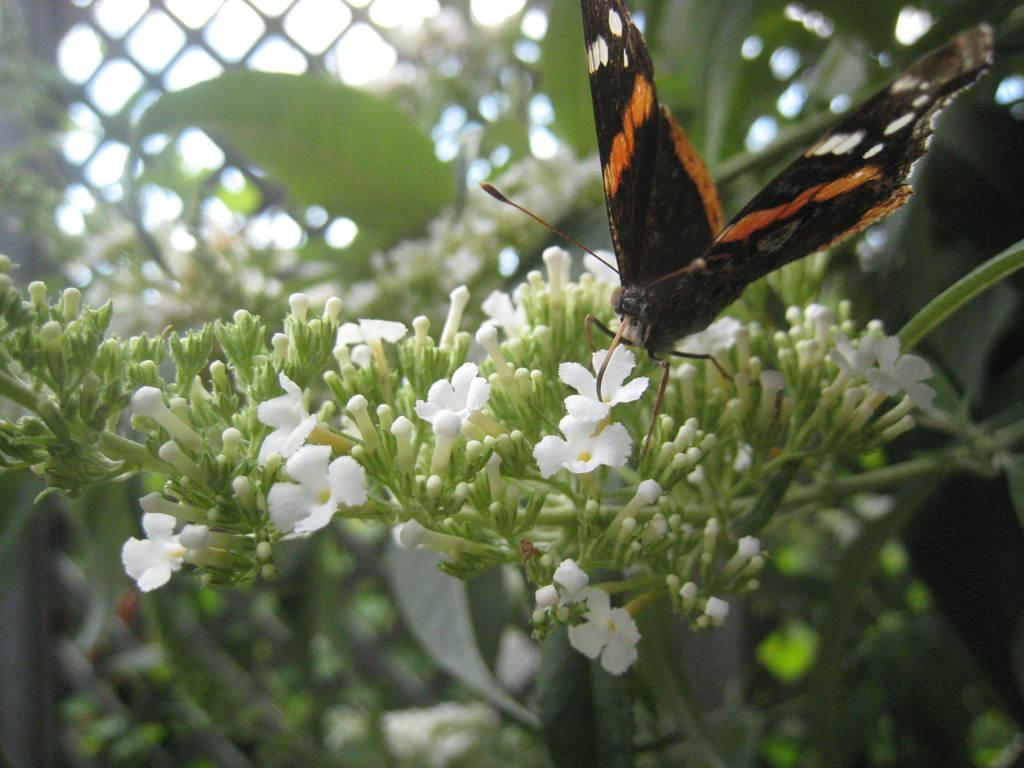What is the main subject of the image? There is a butterfly in the image. Where is the butterfly located in relation to the flowers? The butterfly is on flowers. Can you describe the position of the butterfly in the image? The butterfly is located in the middle of the image. How many deer are visible in the image? There are no deer present in the image; it features a butterfly on flowers. What type of sock is the butterfly wearing in the image? Butterflies do not wear socks, and there is no sock present in the image. 